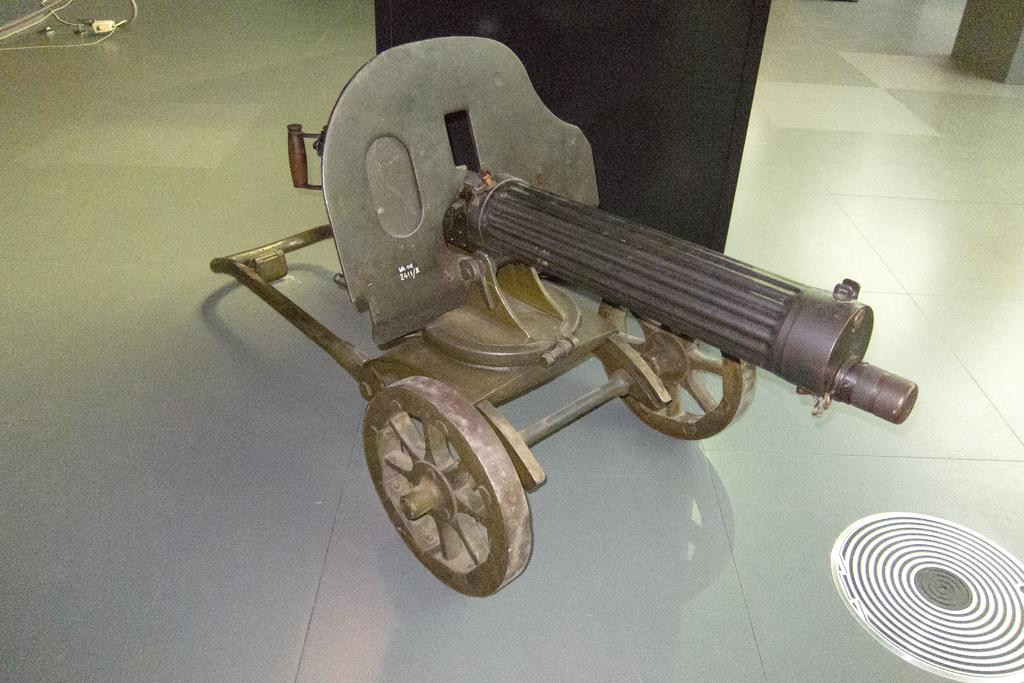What type of weapon is present in the image? There is a maxim gun in the image. What surface can be seen beneath the weapon? There is a floor visible in the image. What type of love can be seen between the people in the image? There are no people present in the image, and therefore no love can be observed. 